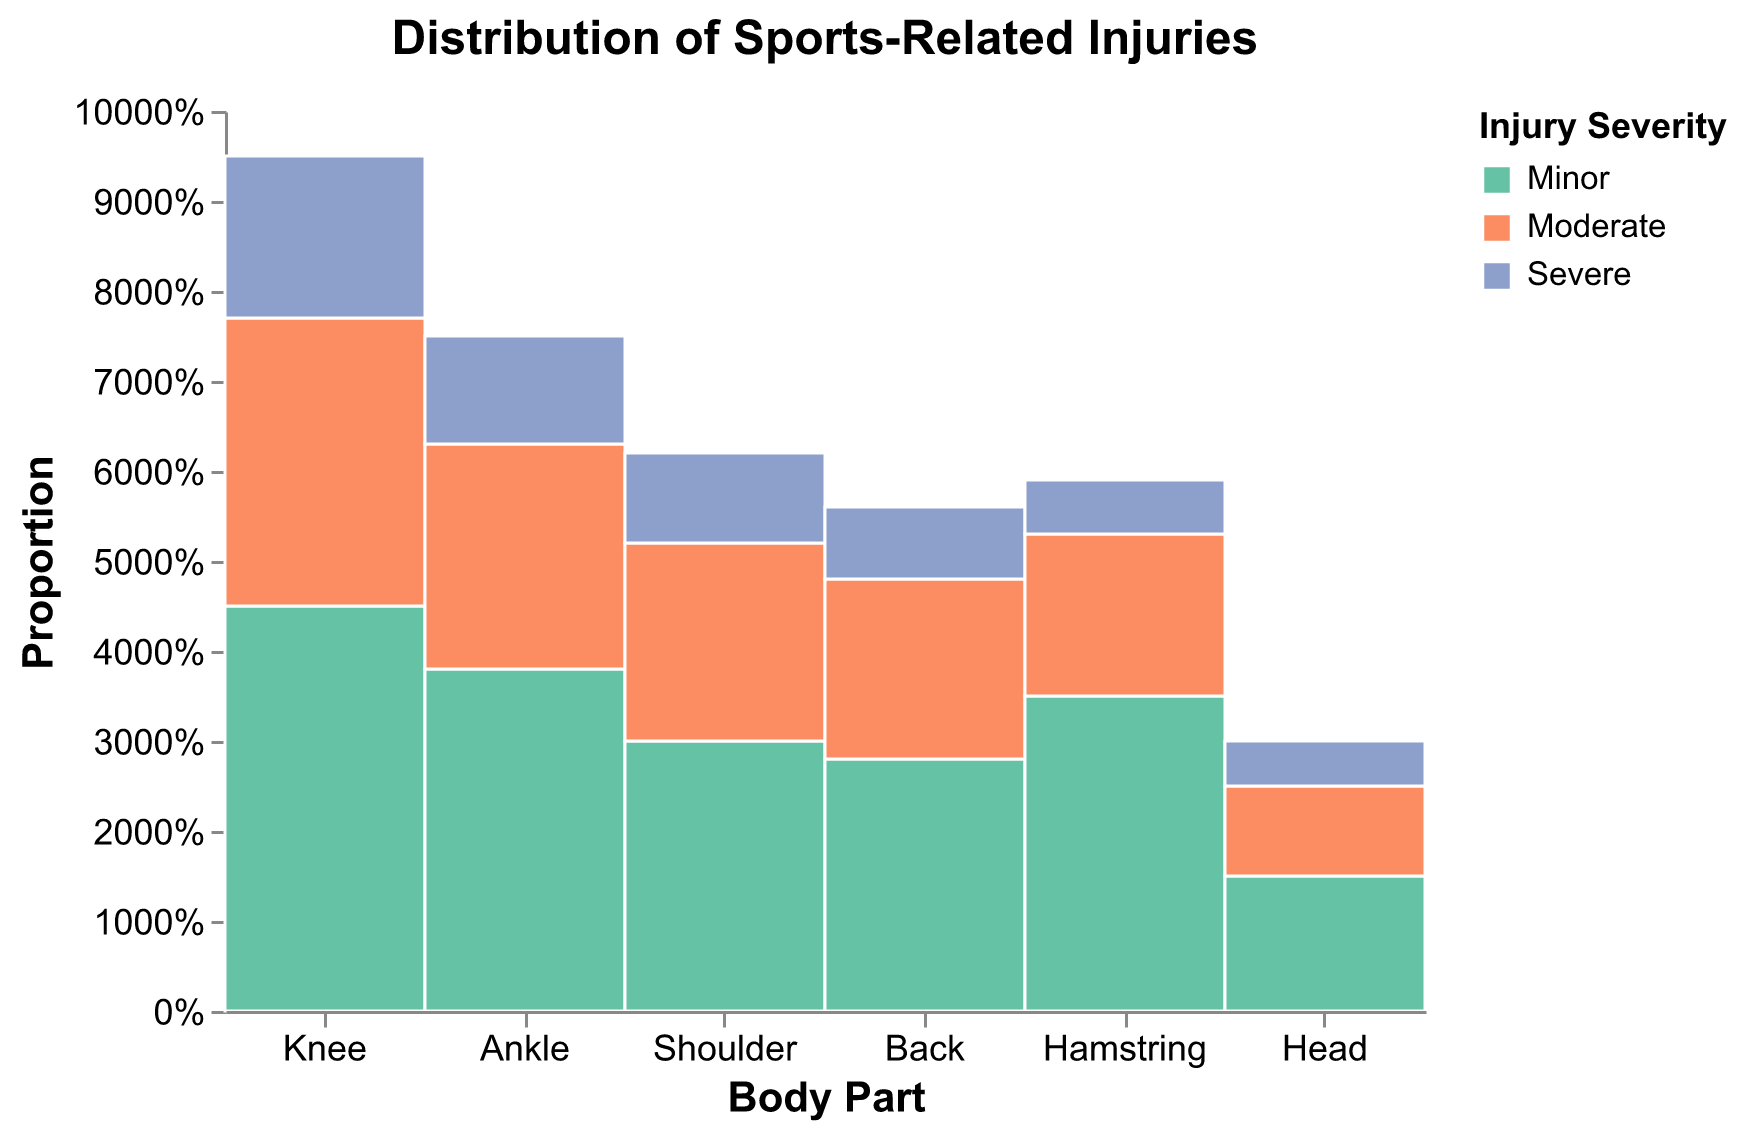What body part shows the highest number of minor injuries? The mosaic plot shows that the body part with the highest proportion for minor injuries is the Knee, indicated by the larger portion in green (color for minor injuries).
Answer: Knee Which injury severity has the smallest representation for head injuries? The section for Head injuries has the smallest division for severe injuries (blue color), compared to moderate and minor.
Answer: Severe How many more moderate knee injuries are there compared to severe knee injuries? Referring to the plot, moderate knee injuries have a proportion represented by a larger segment compared to severe knee injuries. There are 32 moderate knee injuries and 18 severe ones. So, 32 - 18 = 14.
Answer: 14 Which body part has the highest proportion of severe injuries? By examining the plot, the Knee shows the largest blue section, which indicates severe injuries, relative to the proportions of other body parts.
Answer: Knee What percentage of hamstring injuries are severe? Looking at the portion labeled "Hamstring" in the mosaic plot, the blue section (severe injuries) gives the percentage. It represents approximately 10-15% of the total hamstring injuries, considering the normalized view.
Answer: Around 10-15% Which type of injury is more common for ankle injuries, minor or moderate? The green section for minor injuries in the Ankle category is larger compared to the orange section for moderate injuries. So, minor injuries are more common.
Answer: Minor How does the total number of shoulder injuries compare to the total number of back injuries? The total sizes of the blocks for the Shoulder and Back categories in the mosaic plot show that the total number of shoulder injuries is roughly similar to the total number of back injuries. From the data, Shoulder (30+22+10=62) and Back (28+20+8=56) show close counts.
Answer: Similar What body part has the fewest overall injuries? By glancing over the mosaic plot, the smallest category, indicating the fewest injuries overall, is the Head.
Answer: Head What can you infer about the severity distribution of knee injuries compared to ankle injuries? By analyzing the mosaic plot, the knee injuries are proportionally more severe (blue) compared to ankle injuries which have a larger proportion of minor (green) injuries.
Answer: Knee injuries are more severe proportionally Which body part is likely to have the lowest risk of severe injuries? The mosaic plot illustrates that the body part with the smallest blue (severe injuries) section relative to its minor and moderate categories is the Head.
Answer: Head 